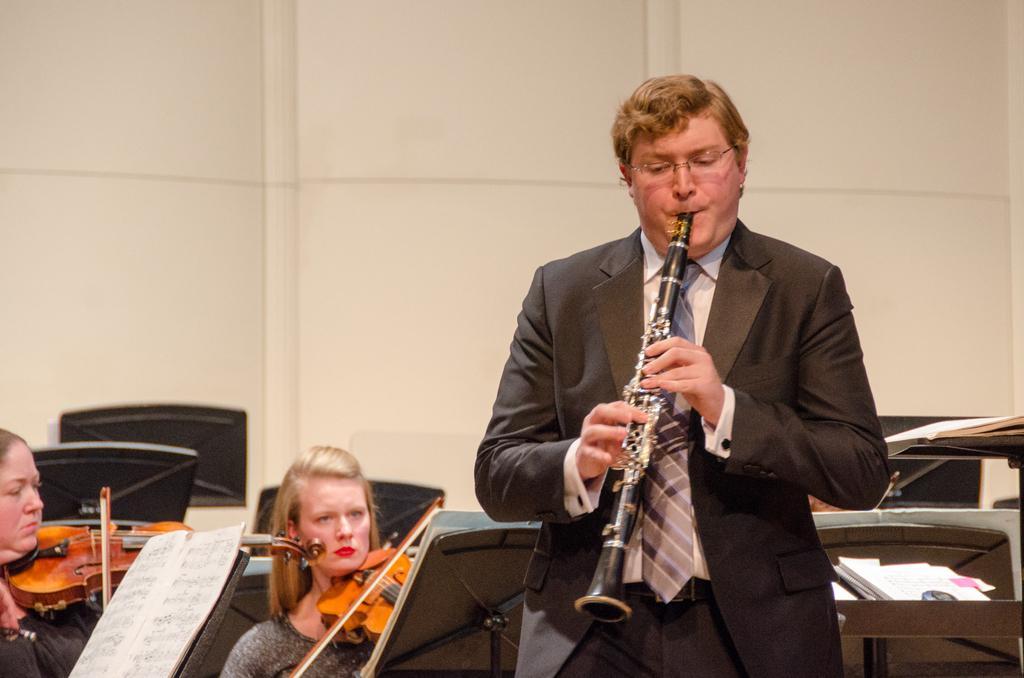In one or two sentences, can you explain what this image depicts? In this image I can see a person wearing shirt, tie and blazer is standing and holding a musical instrument in his hand. In the background I can see few boards, few papers, few persons holding musical instruments and the cream colored surface. 